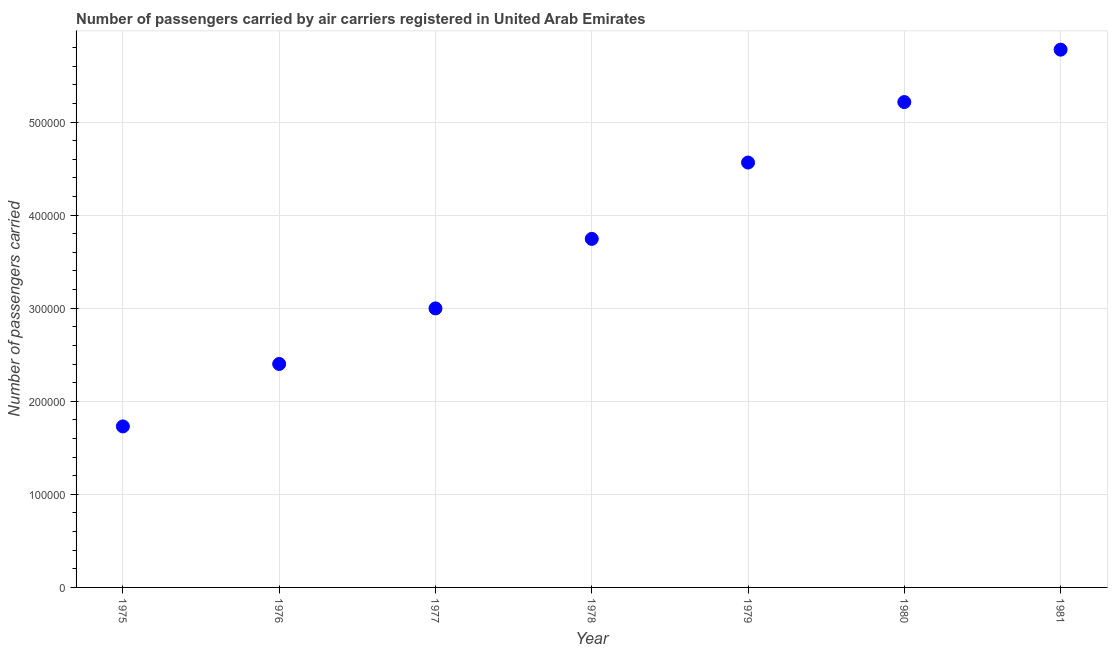What is the number of passengers carried in 1979?
Your answer should be compact. 4.56e+05. Across all years, what is the maximum number of passengers carried?
Keep it short and to the point. 5.78e+05. Across all years, what is the minimum number of passengers carried?
Provide a succinct answer. 1.73e+05. In which year was the number of passengers carried maximum?
Keep it short and to the point. 1981. In which year was the number of passengers carried minimum?
Your answer should be very brief. 1975. What is the sum of the number of passengers carried?
Offer a terse response. 2.64e+06. What is the difference between the number of passengers carried in 1979 and 1981?
Your answer should be very brief. -1.21e+05. What is the average number of passengers carried per year?
Your answer should be very brief. 3.78e+05. What is the median number of passengers carried?
Provide a short and direct response. 3.74e+05. In how many years, is the number of passengers carried greater than 60000 ?
Your answer should be compact. 7. What is the ratio of the number of passengers carried in 1977 to that in 1981?
Keep it short and to the point. 0.52. What is the difference between the highest and the second highest number of passengers carried?
Offer a terse response. 5.63e+04. What is the difference between the highest and the lowest number of passengers carried?
Offer a terse response. 4.05e+05. How many dotlines are there?
Keep it short and to the point. 1. How many years are there in the graph?
Give a very brief answer. 7. What is the difference between two consecutive major ticks on the Y-axis?
Your answer should be compact. 1.00e+05. Does the graph contain grids?
Give a very brief answer. Yes. What is the title of the graph?
Offer a very short reply. Number of passengers carried by air carriers registered in United Arab Emirates. What is the label or title of the X-axis?
Offer a terse response. Year. What is the label or title of the Y-axis?
Make the answer very short. Number of passengers carried. What is the Number of passengers carried in 1975?
Offer a very short reply. 1.73e+05. What is the Number of passengers carried in 1976?
Provide a short and direct response. 2.40e+05. What is the Number of passengers carried in 1977?
Your answer should be compact. 3.00e+05. What is the Number of passengers carried in 1978?
Give a very brief answer. 3.74e+05. What is the Number of passengers carried in 1979?
Keep it short and to the point. 4.56e+05. What is the Number of passengers carried in 1980?
Provide a succinct answer. 5.22e+05. What is the Number of passengers carried in 1981?
Your response must be concise. 5.78e+05. What is the difference between the Number of passengers carried in 1975 and 1976?
Your answer should be compact. -6.71e+04. What is the difference between the Number of passengers carried in 1975 and 1977?
Provide a short and direct response. -1.27e+05. What is the difference between the Number of passengers carried in 1975 and 1978?
Your answer should be compact. -2.02e+05. What is the difference between the Number of passengers carried in 1975 and 1979?
Give a very brief answer. -2.84e+05. What is the difference between the Number of passengers carried in 1975 and 1980?
Give a very brief answer. -3.48e+05. What is the difference between the Number of passengers carried in 1975 and 1981?
Your answer should be compact. -4.05e+05. What is the difference between the Number of passengers carried in 1976 and 1977?
Your answer should be compact. -5.97e+04. What is the difference between the Number of passengers carried in 1976 and 1978?
Your response must be concise. -1.34e+05. What is the difference between the Number of passengers carried in 1976 and 1979?
Your response must be concise. -2.16e+05. What is the difference between the Number of passengers carried in 1976 and 1980?
Ensure brevity in your answer.  -2.81e+05. What is the difference between the Number of passengers carried in 1976 and 1981?
Your answer should be compact. -3.38e+05. What is the difference between the Number of passengers carried in 1977 and 1978?
Ensure brevity in your answer.  -7.47e+04. What is the difference between the Number of passengers carried in 1977 and 1979?
Your response must be concise. -1.57e+05. What is the difference between the Number of passengers carried in 1977 and 1980?
Make the answer very short. -2.22e+05. What is the difference between the Number of passengers carried in 1977 and 1981?
Your answer should be compact. -2.78e+05. What is the difference between the Number of passengers carried in 1978 and 1979?
Your answer should be very brief. -8.20e+04. What is the difference between the Number of passengers carried in 1978 and 1980?
Your answer should be very brief. -1.47e+05. What is the difference between the Number of passengers carried in 1978 and 1981?
Offer a terse response. -2.03e+05. What is the difference between the Number of passengers carried in 1979 and 1980?
Provide a succinct answer. -6.50e+04. What is the difference between the Number of passengers carried in 1979 and 1981?
Ensure brevity in your answer.  -1.21e+05. What is the difference between the Number of passengers carried in 1980 and 1981?
Provide a short and direct response. -5.63e+04. What is the ratio of the Number of passengers carried in 1975 to that in 1976?
Offer a very short reply. 0.72. What is the ratio of the Number of passengers carried in 1975 to that in 1977?
Your answer should be compact. 0.58. What is the ratio of the Number of passengers carried in 1975 to that in 1978?
Your answer should be very brief. 0.46. What is the ratio of the Number of passengers carried in 1975 to that in 1979?
Your response must be concise. 0.38. What is the ratio of the Number of passengers carried in 1975 to that in 1980?
Your answer should be compact. 0.33. What is the ratio of the Number of passengers carried in 1975 to that in 1981?
Provide a short and direct response. 0.3. What is the ratio of the Number of passengers carried in 1976 to that in 1977?
Give a very brief answer. 0.8. What is the ratio of the Number of passengers carried in 1976 to that in 1978?
Give a very brief answer. 0.64. What is the ratio of the Number of passengers carried in 1976 to that in 1979?
Provide a succinct answer. 0.53. What is the ratio of the Number of passengers carried in 1976 to that in 1980?
Keep it short and to the point. 0.46. What is the ratio of the Number of passengers carried in 1976 to that in 1981?
Offer a very short reply. 0.42. What is the ratio of the Number of passengers carried in 1977 to that in 1978?
Give a very brief answer. 0.8. What is the ratio of the Number of passengers carried in 1977 to that in 1979?
Ensure brevity in your answer.  0.66. What is the ratio of the Number of passengers carried in 1977 to that in 1980?
Your response must be concise. 0.57. What is the ratio of the Number of passengers carried in 1977 to that in 1981?
Offer a terse response. 0.52. What is the ratio of the Number of passengers carried in 1978 to that in 1979?
Your response must be concise. 0.82. What is the ratio of the Number of passengers carried in 1978 to that in 1980?
Your answer should be compact. 0.72. What is the ratio of the Number of passengers carried in 1978 to that in 1981?
Ensure brevity in your answer.  0.65. What is the ratio of the Number of passengers carried in 1979 to that in 1981?
Keep it short and to the point. 0.79. What is the ratio of the Number of passengers carried in 1980 to that in 1981?
Your answer should be compact. 0.9. 